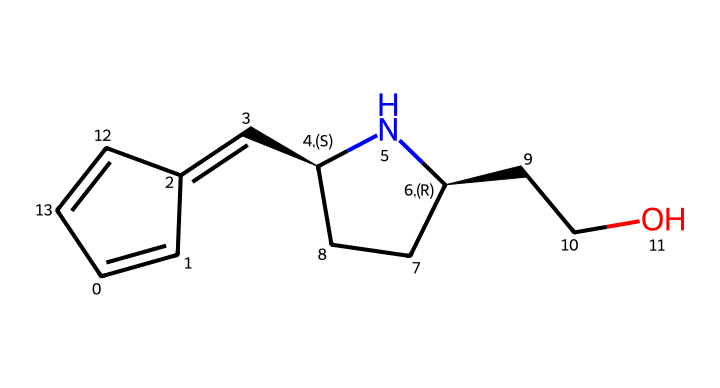what is the molecular formula of the drug represented? By analyzing the SMILES representation, we can count the number of each type of atom. In the structure provided, there are 13 carbon atoms, 15 hydrogen atoms, 1 nitrogen atom, and 1 oxygen atom. The molecular formula is compiled by listing the atoms in the order: C, H, N, O.
Answer: C13H15N1O1 how many rings are present in the structure? The SMILES indicates that the structure contains two distinct cyclic components that can be identified as two rings (C1=CC and the part connected to C@H). Each cycle connects back to the initial atom representation.
Answer: 2 what type of drug is represented by this structure? The presence of a nitrogen atom and the overall structure aligns typically with classifications of psychoactive compounds, specifically those that influence Serotonin levels, thus categorizing it as a serotonin receptor agonist.
Answer: serotonin receptor agonist what is the significance of the nitrogen atom in this structure? The nitrogen atom plays a crucial role in defining the pharmacological properties of the drug by engaging in interactions with Serotonin receptors. It often affects the binding affinity and efficacy of the molecule in terms of mood regulation.
Answer: pharmacological properties which part of this molecule is likely responsible for mood regulation? The cyclic structure attached to the nitrogen, along with the carbon chain leading to it, forms portions that typically engage with the serotonin pathways in the brain and are crucial for influencing mood. The overall arrangement directs how it interacts with serotonin receptors.
Answer: cyclic structure 